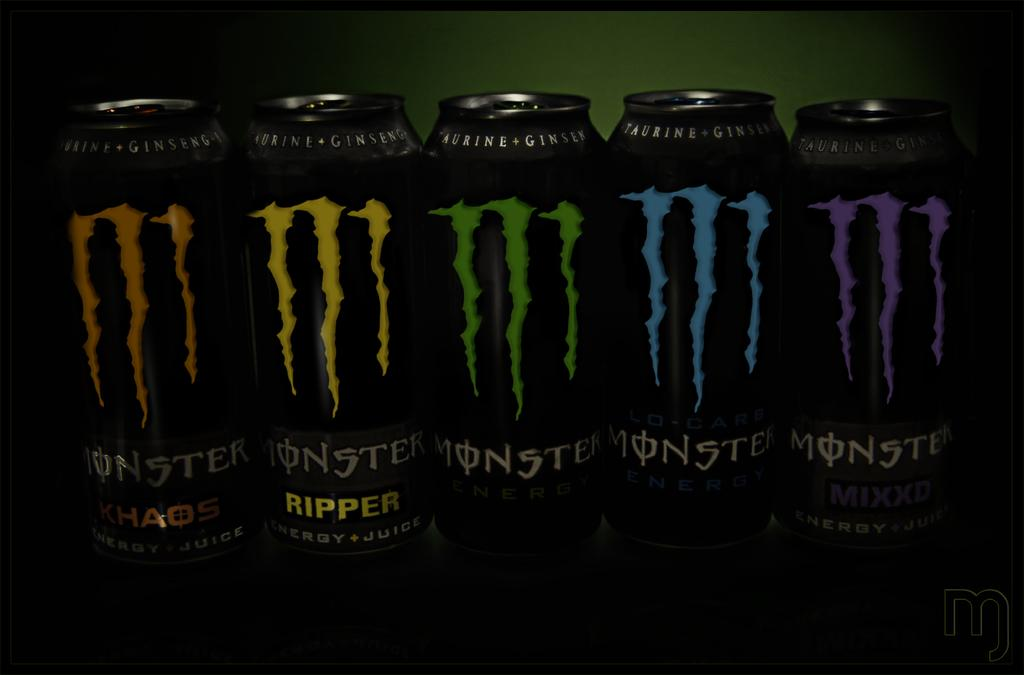<image>
Offer a succinct explanation of the picture presented. Multicolor Monster cans are being displayed in front of a green background. 